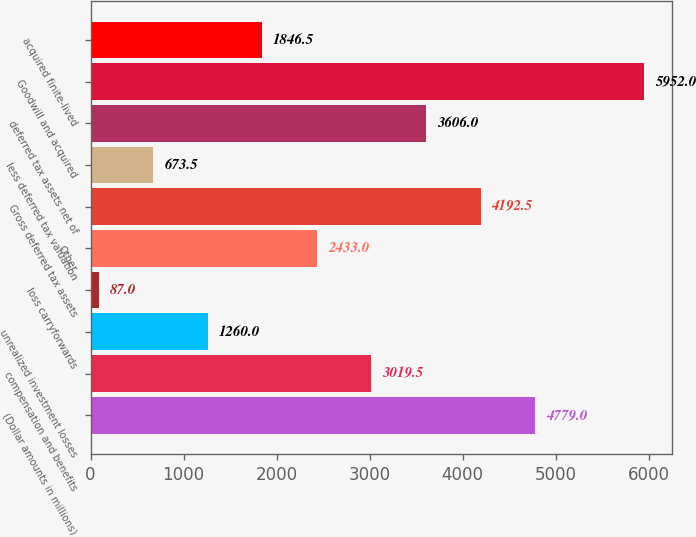Convert chart to OTSL. <chart><loc_0><loc_0><loc_500><loc_500><bar_chart><fcel>(Dollar amounts in millions)<fcel>compensation and benefits<fcel>unrealized investment losses<fcel>loss carryforwards<fcel>Other<fcel>Gross deferred tax assets<fcel>less deferred tax valuation<fcel>deferred tax assets net of<fcel>Goodwill and acquired<fcel>acquired finite-lived<nl><fcel>4779<fcel>3019.5<fcel>1260<fcel>87<fcel>2433<fcel>4192.5<fcel>673.5<fcel>3606<fcel>5952<fcel>1846.5<nl></chart> 